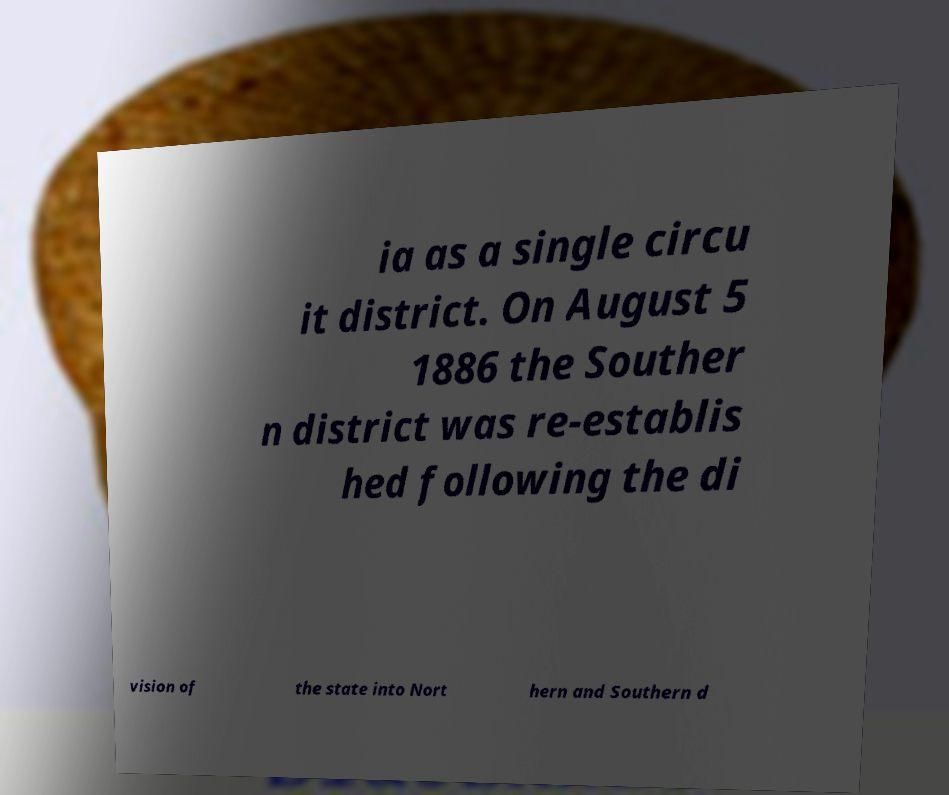For documentation purposes, I need the text within this image transcribed. Could you provide that? ia as a single circu it district. On August 5 1886 the Souther n district was re-establis hed following the di vision of the state into Nort hern and Southern d 